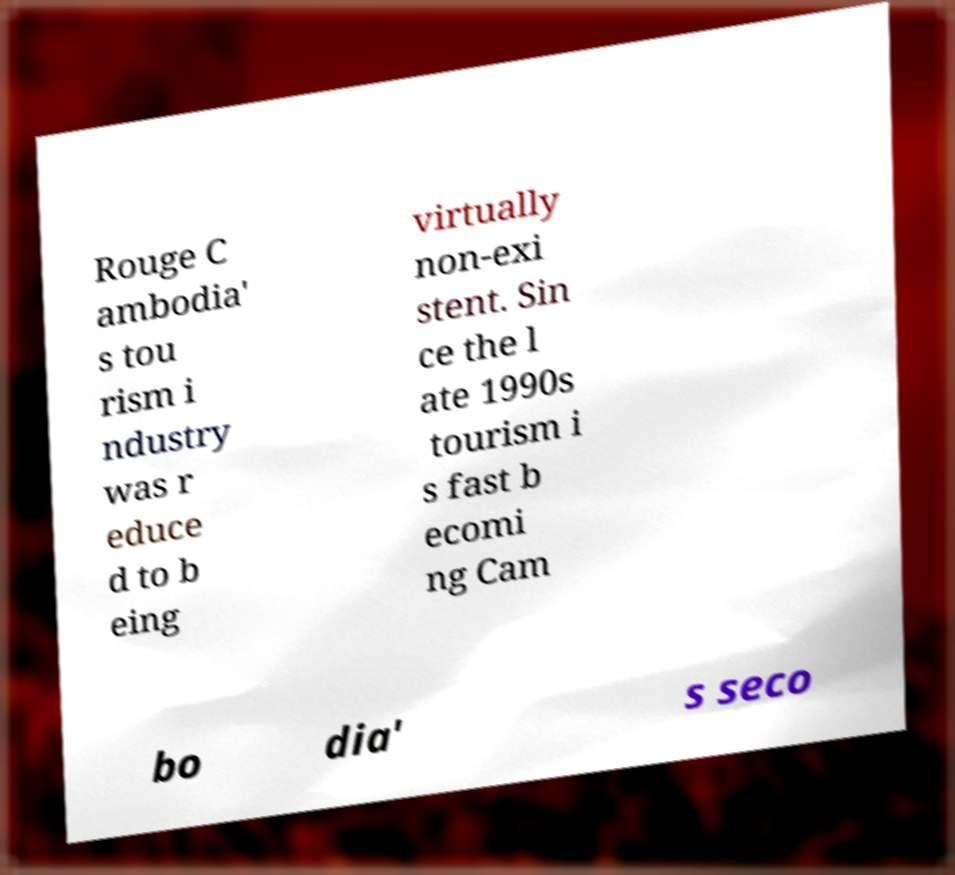Can you read and provide the text displayed in the image?This photo seems to have some interesting text. Can you extract and type it out for me? Rouge C ambodia' s tou rism i ndustry was r educe d to b eing virtually non-exi stent. Sin ce the l ate 1990s tourism i s fast b ecomi ng Cam bo dia' s seco 